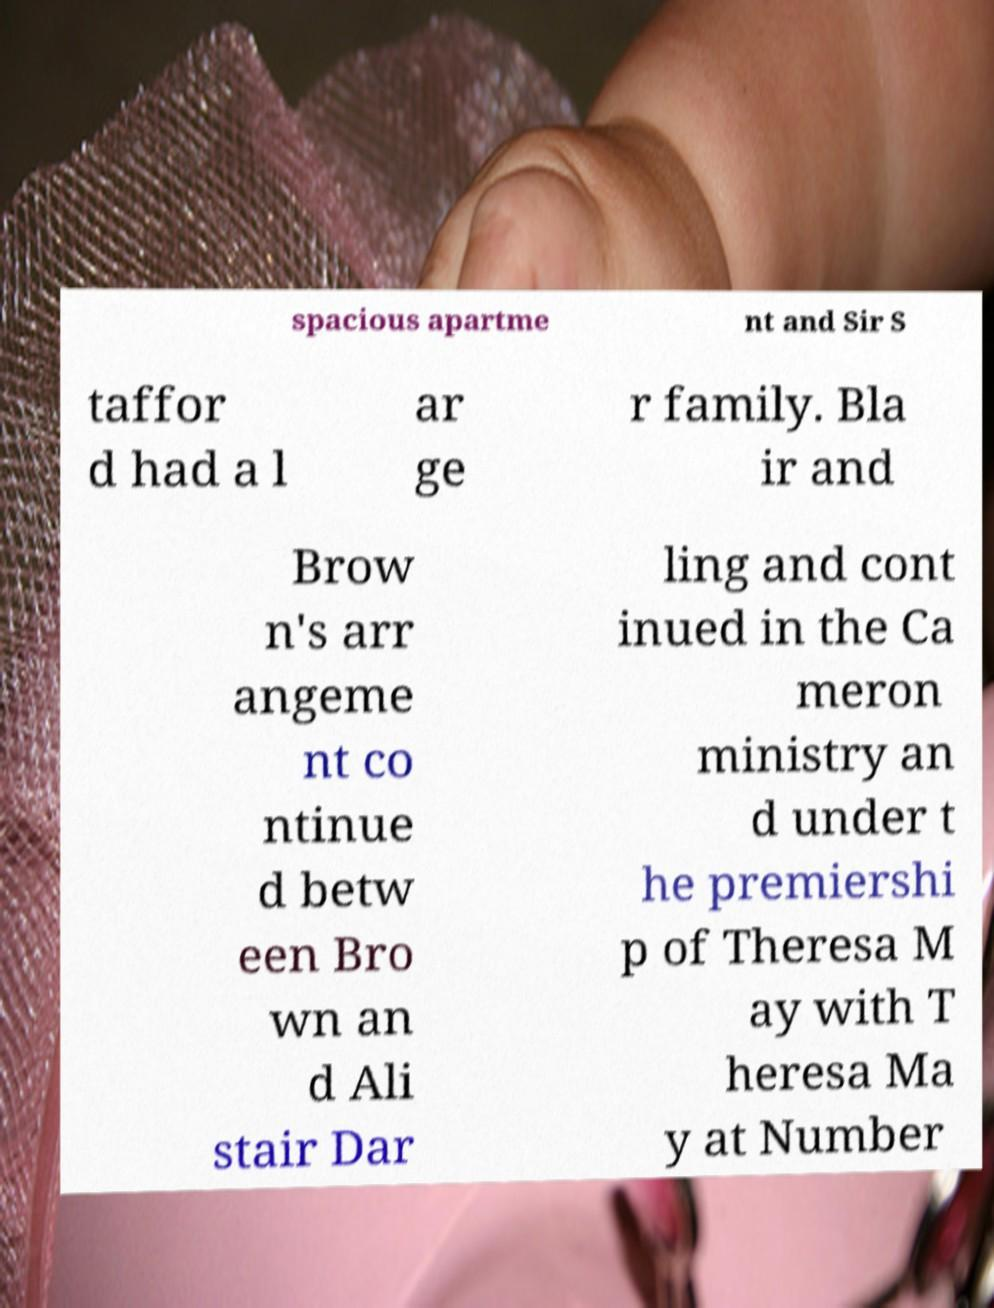I need the written content from this picture converted into text. Can you do that? spacious apartme nt and Sir S taffor d had a l ar ge r family. Bla ir and Brow n's arr angeme nt co ntinue d betw een Bro wn an d Ali stair Dar ling and cont inued in the Ca meron ministry an d under t he premiershi p of Theresa M ay with T heresa Ma y at Number 